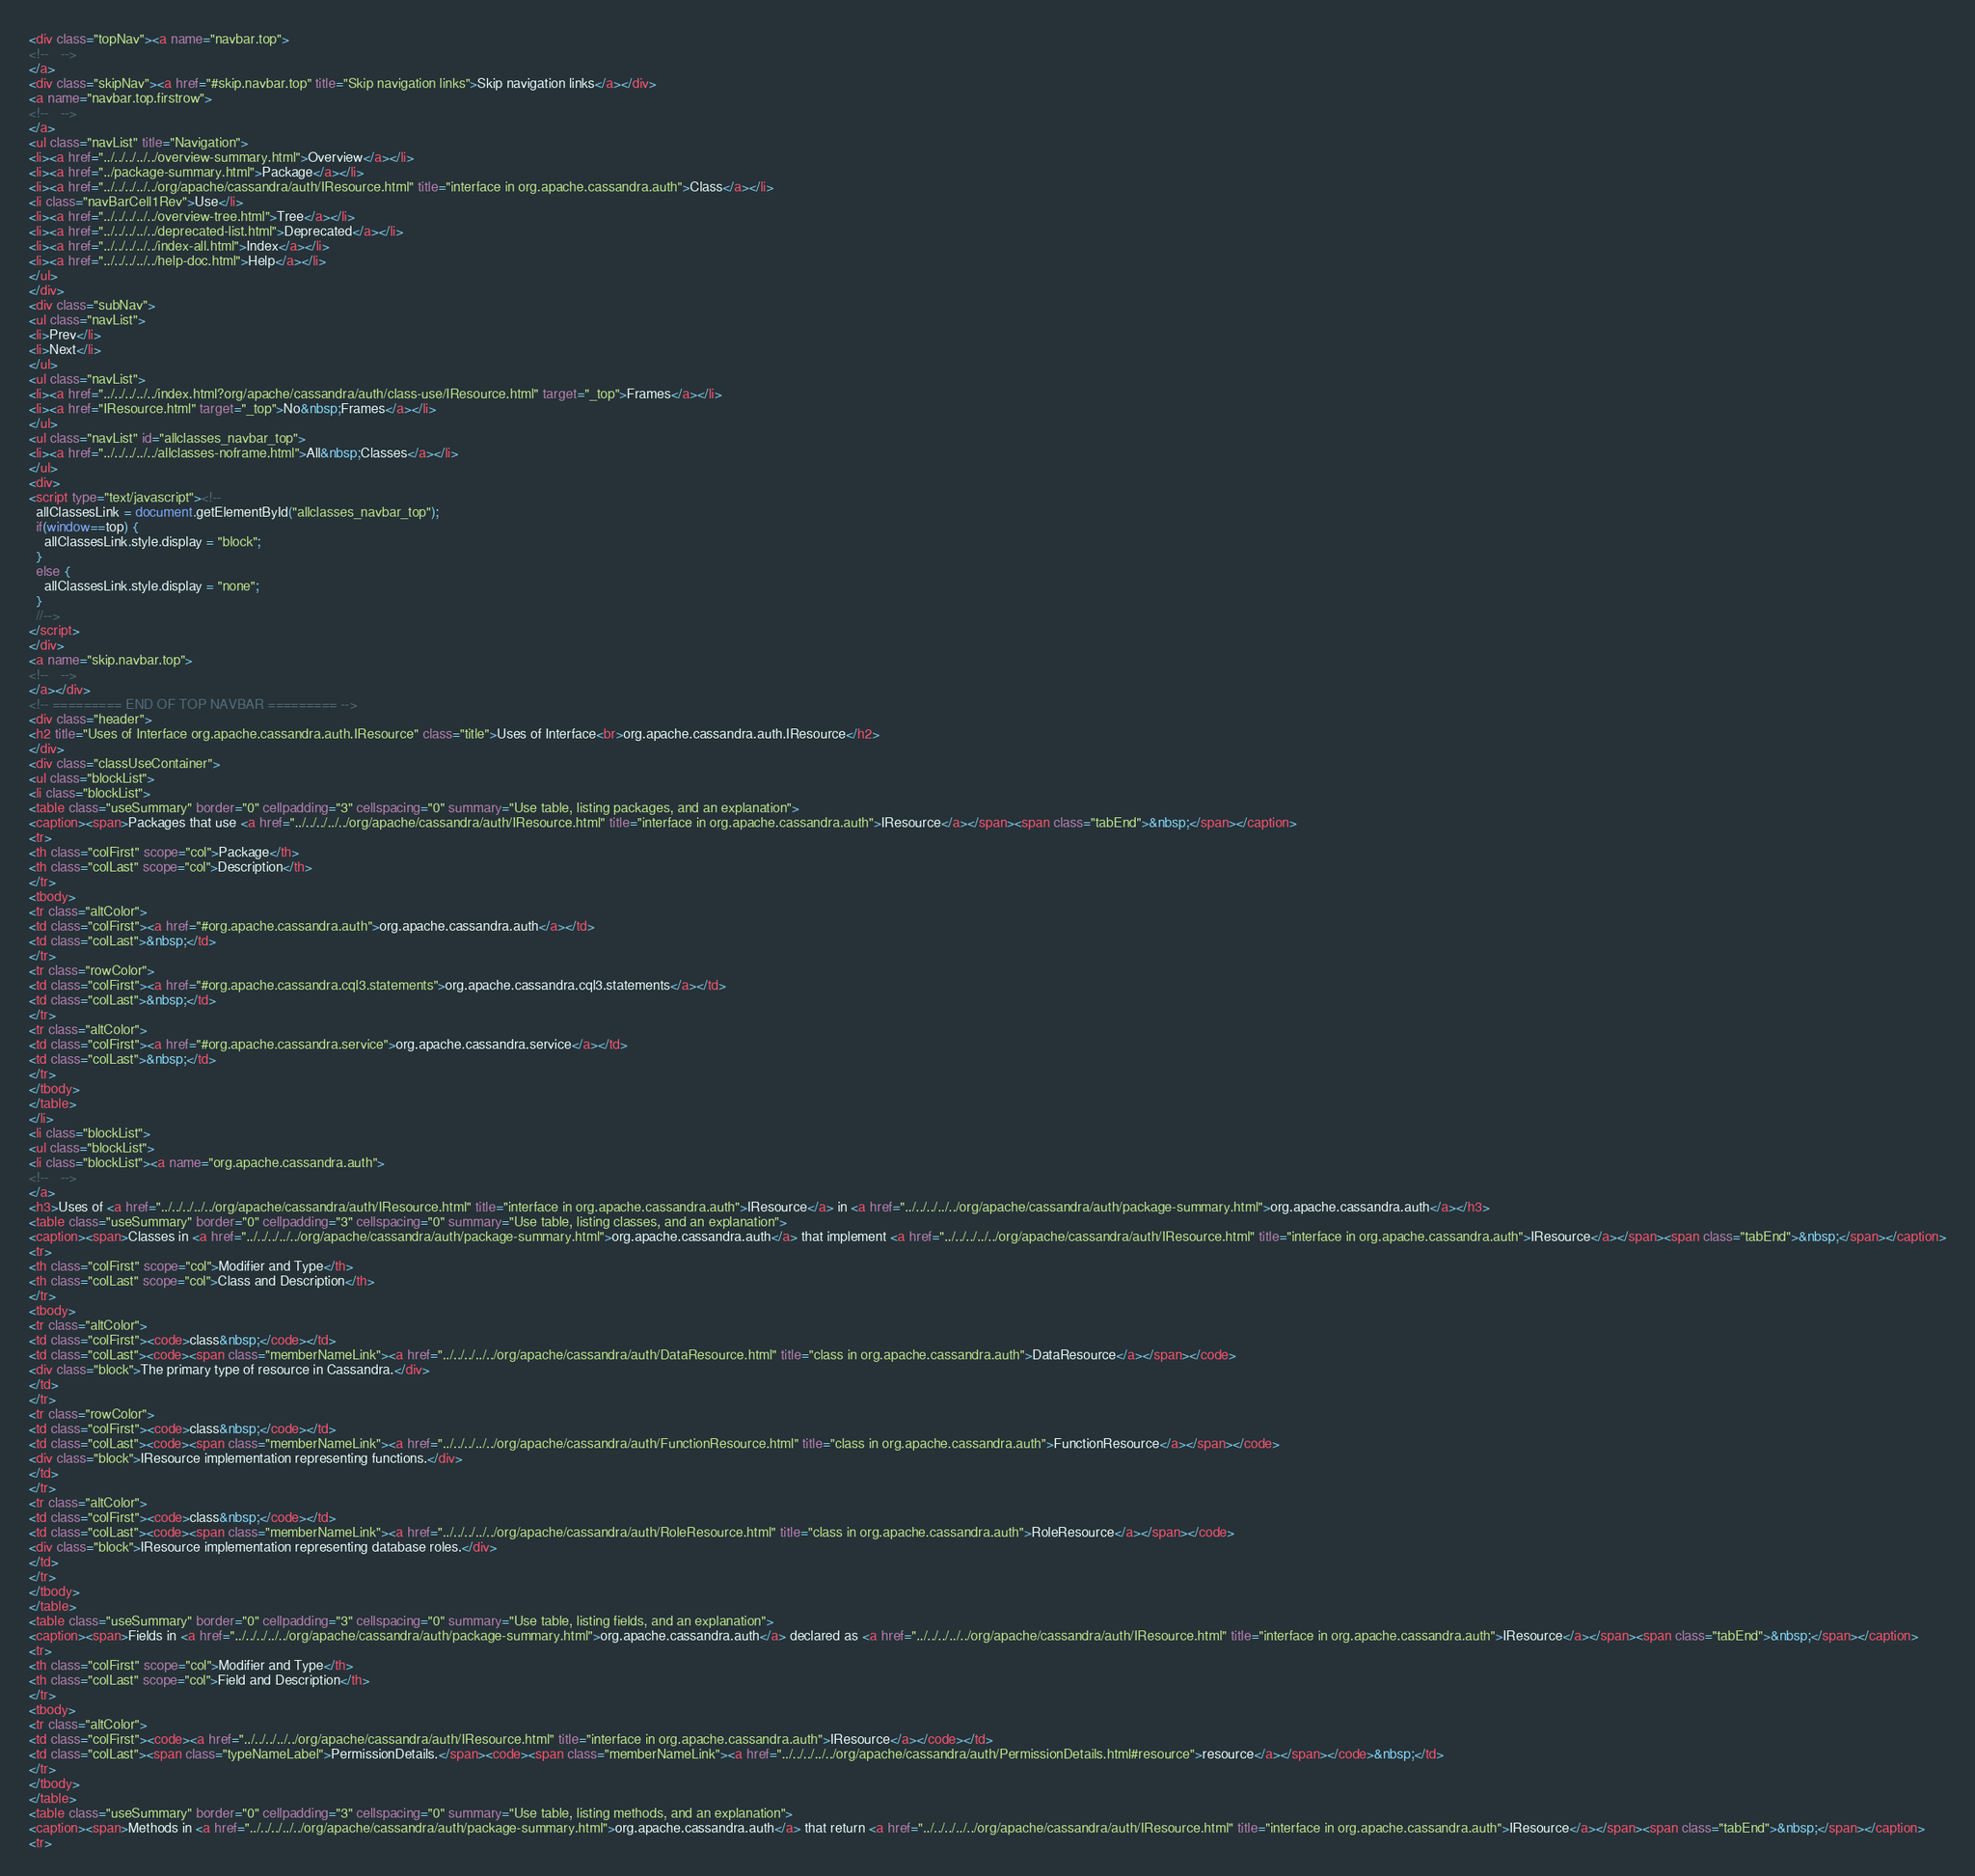Convert code to text. <code><loc_0><loc_0><loc_500><loc_500><_HTML_><div class="topNav"><a name="navbar.top">
<!--   -->
</a>
<div class="skipNav"><a href="#skip.navbar.top" title="Skip navigation links">Skip navigation links</a></div>
<a name="navbar.top.firstrow">
<!--   -->
</a>
<ul class="navList" title="Navigation">
<li><a href="../../../../../overview-summary.html">Overview</a></li>
<li><a href="../package-summary.html">Package</a></li>
<li><a href="../../../../../org/apache/cassandra/auth/IResource.html" title="interface in org.apache.cassandra.auth">Class</a></li>
<li class="navBarCell1Rev">Use</li>
<li><a href="../../../../../overview-tree.html">Tree</a></li>
<li><a href="../../../../../deprecated-list.html">Deprecated</a></li>
<li><a href="../../../../../index-all.html">Index</a></li>
<li><a href="../../../../../help-doc.html">Help</a></li>
</ul>
</div>
<div class="subNav">
<ul class="navList">
<li>Prev</li>
<li>Next</li>
</ul>
<ul class="navList">
<li><a href="../../../../../index.html?org/apache/cassandra/auth/class-use/IResource.html" target="_top">Frames</a></li>
<li><a href="IResource.html" target="_top">No&nbsp;Frames</a></li>
</ul>
<ul class="navList" id="allclasses_navbar_top">
<li><a href="../../../../../allclasses-noframe.html">All&nbsp;Classes</a></li>
</ul>
<div>
<script type="text/javascript"><!--
  allClassesLink = document.getElementById("allclasses_navbar_top");
  if(window==top) {
    allClassesLink.style.display = "block";
  }
  else {
    allClassesLink.style.display = "none";
  }
  //-->
</script>
</div>
<a name="skip.navbar.top">
<!--   -->
</a></div>
<!-- ========= END OF TOP NAVBAR ========= -->
<div class="header">
<h2 title="Uses of Interface org.apache.cassandra.auth.IResource" class="title">Uses of Interface<br>org.apache.cassandra.auth.IResource</h2>
</div>
<div class="classUseContainer">
<ul class="blockList">
<li class="blockList">
<table class="useSummary" border="0" cellpadding="3" cellspacing="0" summary="Use table, listing packages, and an explanation">
<caption><span>Packages that use <a href="../../../../../org/apache/cassandra/auth/IResource.html" title="interface in org.apache.cassandra.auth">IResource</a></span><span class="tabEnd">&nbsp;</span></caption>
<tr>
<th class="colFirst" scope="col">Package</th>
<th class="colLast" scope="col">Description</th>
</tr>
<tbody>
<tr class="altColor">
<td class="colFirst"><a href="#org.apache.cassandra.auth">org.apache.cassandra.auth</a></td>
<td class="colLast">&nbsp;</td>
</tr>
<tr class="rowColor">
<td class="colFirst"><a href="#org.apache.cassandra.cql3.statements">org.apache.cassandra.cql3.statements</a></td>
<td class="colLast">&nbsp;</td>
</tr>
<tr class="altColor">
<td class="colFirst"><a href="#org.apache.cassandra.service">org.apache.cassandra.service</a></td>
<td class="colLast">&nbsp;</td>
</tr>
</tbody>
</table>
</li>
<li class="blockList">
<ul class="blockList">
<li class="blockList"><a name="org.apache.cassandra.auth">
<!--   -->
</a>
<h3>Uses of <a href="../../../../../org/apache/cassandra/auth/IResource.html" title="interface in org.apache.cassandra.auth">IResource</a> in <a href="../../../../../org/apache/cassandra/auth/package-summary.html">org.apache.cassandra.auth</a></h3>
<table class="useSummary" border="0" cellpadding="3" cellspacing="0" summary="Use table, listing classes, and an explanation">
<caption><span>Classes in <a href="../../../../../org/apache/cassandra/auth/package-summary.html">org.apache.cassandra.auth</a> that implement <a href="../../../../../org/apache/cassandra/auth/IResource.html" title="interface in org.apache.cassandra.auth">IResource</a></span><span class="tabEnd">&nbsp;</span></caption>
<tr>
<th class="colFirst" scope="col">Modifier and Type</th>
<th class="colLast" scope="col">Class and Description</th>
</tr>
<tbody>
<tr class="altColor">
<td class="colFirst"><code>class&nbsp;</code></td>
<td class="colLast"><code><span class="memberNameLink"><a href="../../../../../org/apache/cassandra/auth/DataResource.html" title="class in org.apache.cassandra.auth">DataResource</a></span></code>
<div class="block">The primary type of resource in Cassandra.</div>
</td>
</tr>
<tr class="rowColor">
<td class="colFirst"><code>class&nbsp;</code></td>
<td class="colLast"><code><span class="memberNameLink"><a href="../../../../../org/apache/cassandra/auth/FunctionResource.html" title="class in org.apache.cassandra.auth">FunctionResource</a></span></code>
<div class="block">IResource implementation representing functions.</div>
</td>
</tr>
<tr class="altColor">
<td class="colFirst"><code>class&nbsp;</code></td>
<td class="colLast"><code><span class="memberNameLink"><a href="../../../../../org/apache/cassandra/auth/RoleResource.html" title="class in org.apache.cassandra.auth">RoleResource</a></span></code>
<div class="block">IResource implementation representing database roles.</div>
</td>
</tr>
</tbody>
</table>
<table class="useSummary" border="0" cellpadding="3" cellspacing="0" summary="Use table, listing fields, and an explanation">
<caption><span>Fields in <a href="../../../../../org/apache/cassandra/auth/package-summary.html">org.apache.cassandra.auth</a> declared as <a href="../../../../../org/apache/cassandra/auth/IResource.html" title="interface in org.apache.cassandra.auth">IResource</a></span><span class="tabEnd">&nbsp;</span></caption>
<tr>
<th class="colFirst" scope="col">Modifier and Type</th>
<th class="colLast" scope="col">Field and Description</th>
</tr>
<tbody>
<tr class="altColor">
<td class="colFirst"><code><a href="../../../../../org/apache/cassandra/auth/IResource.html" title="interface in org.apache.cassandra.auth">IResource</a></code></td>
<td class="colLast"><span class="typeNameLabel">PermissionDetails.</span><code><span class="memberNameLink"><a href="../../../../../org/apache/cassandra/auth/PermissionDetails.html#resource">resource</a></span></code>&nbsp;</td>
</tr>
</tbody>
</table>
<table class="useSummary" border="0" cellpadding="3" cellspacing="0" summary="Use table, listing methods, and an explanation">
<caption><span>Methods in <a href="../../../../../org/apache/cassandra/auth/package-summary.html">org.apache.cassandra.auth</a> that return <a href="../../../../../org/apache/cassandra/auth/IResource.html" title="interface in org.apache.cassandra.auth">IResource</a></span><span class="tabEnd">&nbsp;</span></caption>
<tr></code> 